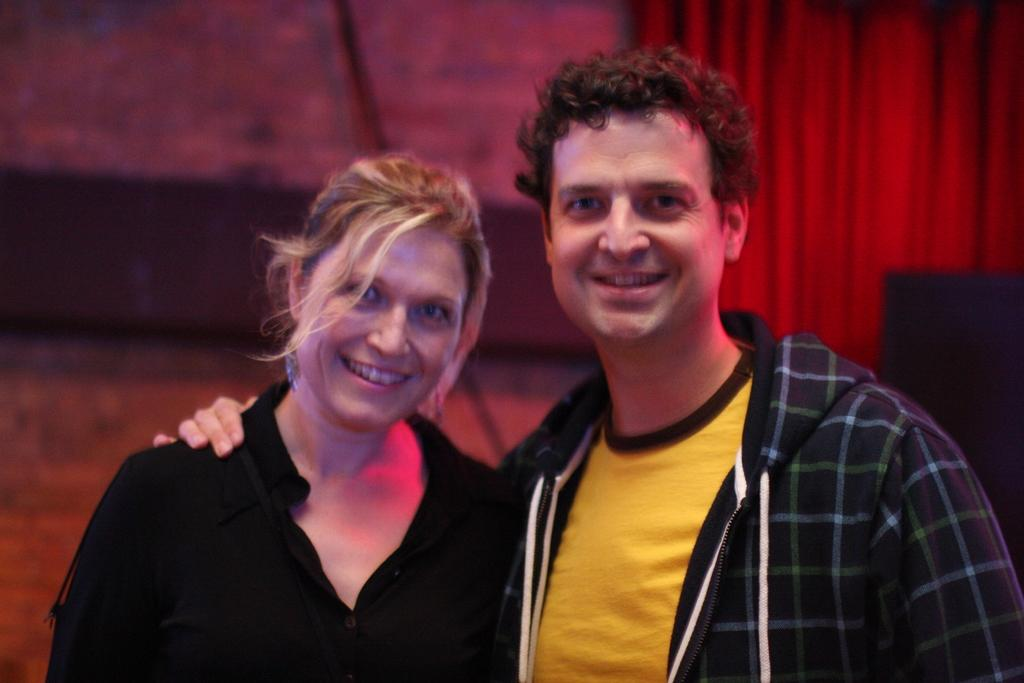Who can be seen in the image? There is a woman and a man in the image. What are the expressions on their faces? Both the woman and the man are smiling in the image. What are they doing in the image? They are posing for the picture. What can be seen in the background of the image? There is a wall and a curtain in the background of the image. What type of hat is the rabbit wearing in the image? There is no rabbit present in the image, and therefore no hat or any other accessory can be observed on a rabbit. 